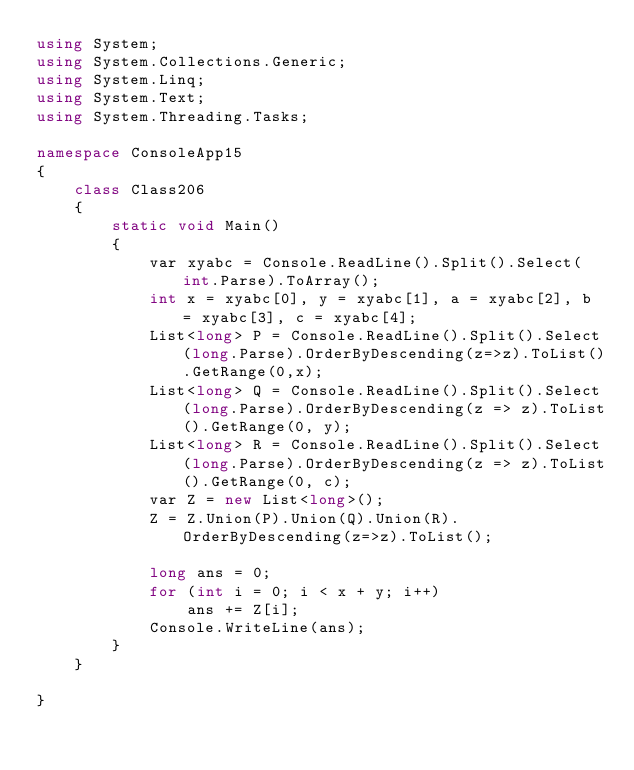Convert code to text. <code><loc_0><loc_0><loc_500><loc_500><_C#_>using System;
using System.Collections.Generic;
using System.Linq;
using System.Text;
using System.Threading.Tasks;

namespace ConsoleApp15
{
    class Class206
    {
        static void Main()
        {
            var xyabc = Console.ReadLine().Split().Select(int.Parse).ToArray();
            int x = xyabc[0], y = xyabc[1], a = xyabc[2], b = xyabc[3], c = xyabc[4];
            List<long> P = Console.ReadLine().Split().Select(long.Parse).OrderByDescending(z=>z).ToList().GetRange(0,x);
            List<long> Q = Console.ReadLine().Split().Select(long.Parse).OrderByDescending(z => z).ToList().GetRange(0, y);
            List<long> R = Console.ReadLine().Split().Select(long.Parse).OrderByDescending(z => z).ToList().GetRange(0, c);
            var Z = new List<long>();
            Z = Z.Union(P).Union(Q).Union(R).OrderByDescending(z=>z).ToList();
            
            long ans = 0;
            for (int i = 0; i < x + y; i++)
                ans += Z[i];
            Console.WriteLine(ans);
        }
    }

}
</code> 